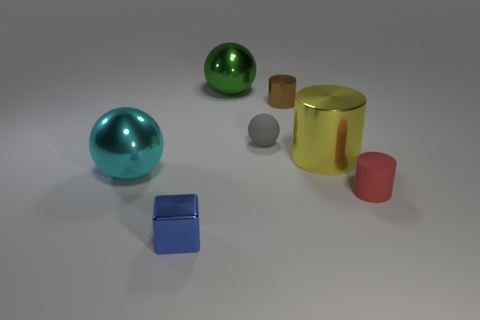What material is the brown cylinder that is the same size as the gray sphere?
Ensure brevity in your answer.  Metal. Is the number of brown shiny things in front of the blue metal block the same as the number of things that are in front of the tiny matte sphere?
Ensure brevity in your answer.  No. What number of big metal balls are right of the tiny matte thing on the right side of the brown object that is left of the large yellow object?
Your response must be concise. 0. Do the small cube and the small cylinder that is behind the red thing have the same color?
Make the answer very short. No. The brown object that is the same material as the blue block is what size?
Keep it short and to the point. Small. Is the number of small red cylinders to the left of the big cylinder greater than the number of matte spheres?
Offer a terse response. No. There is a big ball behind the tiny cylinder that is behind the shiny thing that is to the left of the metallic block; what is its material?
Offer a terse response. Metal. Are the small red cylinder and the green thing behind the big cyan object made of the same material?
Make the answer very short. No. There is a large green thing that is the same shape as the large cyan metallic thing; what is it made of?
Make the answer very short. Metal. Is there anything else that is the same material as the green object?
Your response must be concise. Yes. 